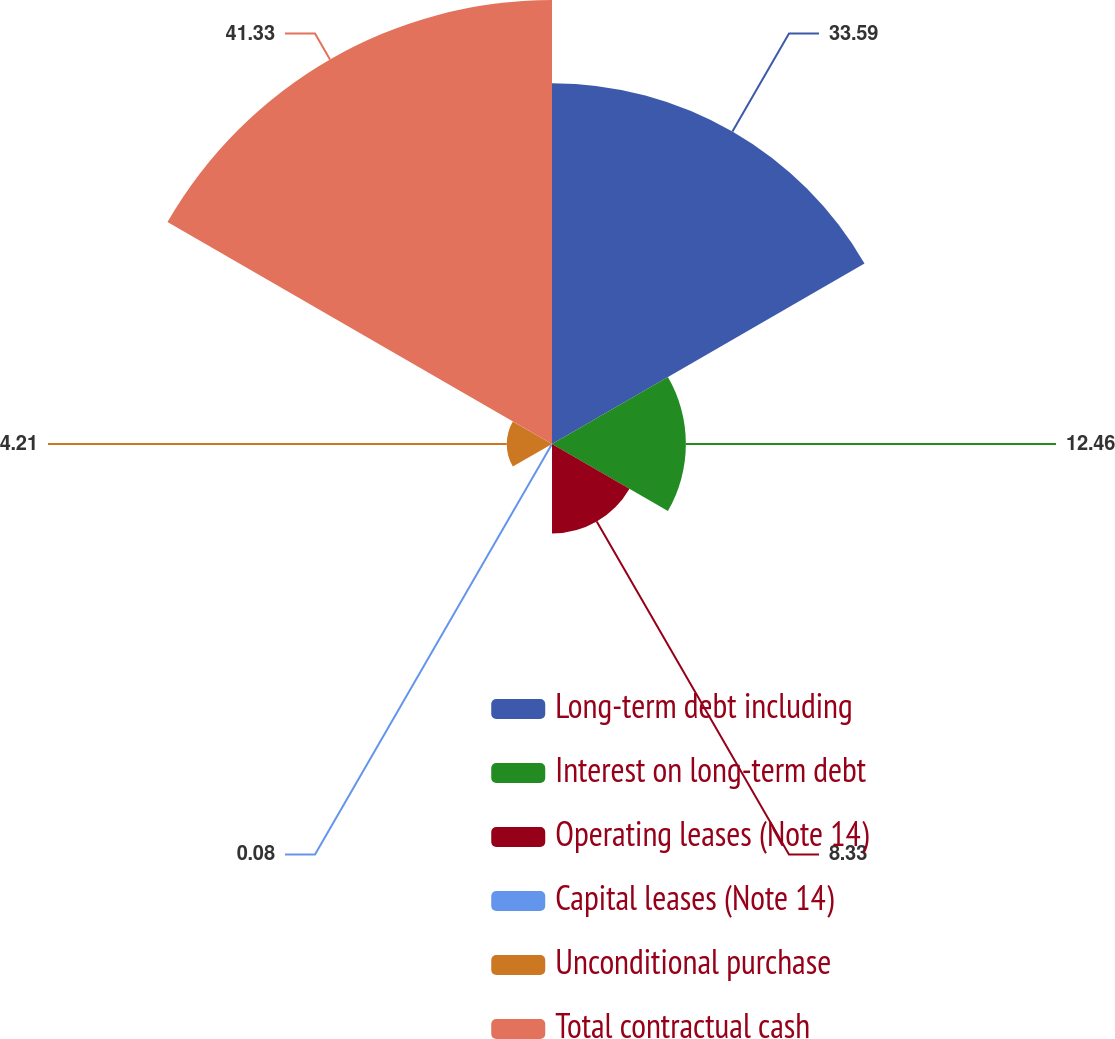<chart> <loc_0><loc_0><loc_500><loc_500><pie_chart><fcel>Long-term debt including<fcel>Interest on long-term debt<fcel>Operating leases (Note 14)<fcel>Capital leases (Note 14)<fcel>Unconditional purchase<fcel>Total contractual cash<nl><fcel>33.59%<fcel>12.46%<fcel>8.33%<fcel>0.08%<fcel>4.21%<fcel>41.33%<nl></chart> 